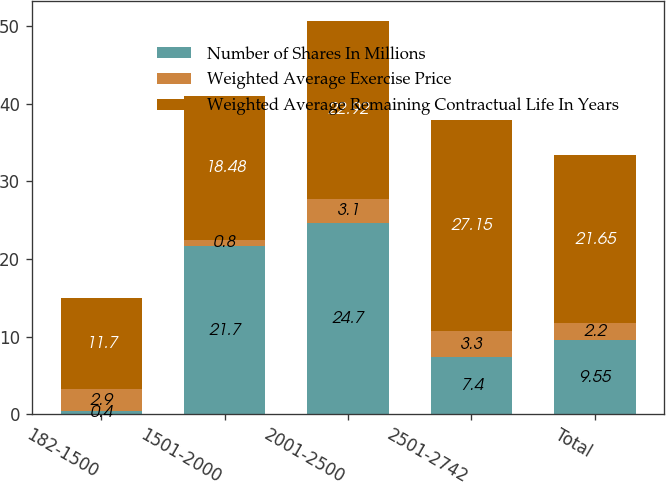Convert chart. <chart><loc_0><loc_0><loc_500><loc_500><stacked_bar_chart><ecel><fcel>182-1500<fcel>1501-2000<fcel>2001-2500<fcel>2501-2742<fcel>Total<nl><fcel>Number of Shares In Millions<fcel>0.4<fcel>21.7<fcel>24.7<fcel>7.4<fcel>9.55<nl><fcel>Weighted Average Exercise Price<fcel>2.9<fcel>0.8<fcel>3.1<fcel>3.3<fcel>2.2<nl><fcel>Weighted Average Remaining Contractual Life In Years<fcel>11.7<fcel>18.48<fcel>22.92<fcel>27.15<fcel>21.65<nl></chart> 